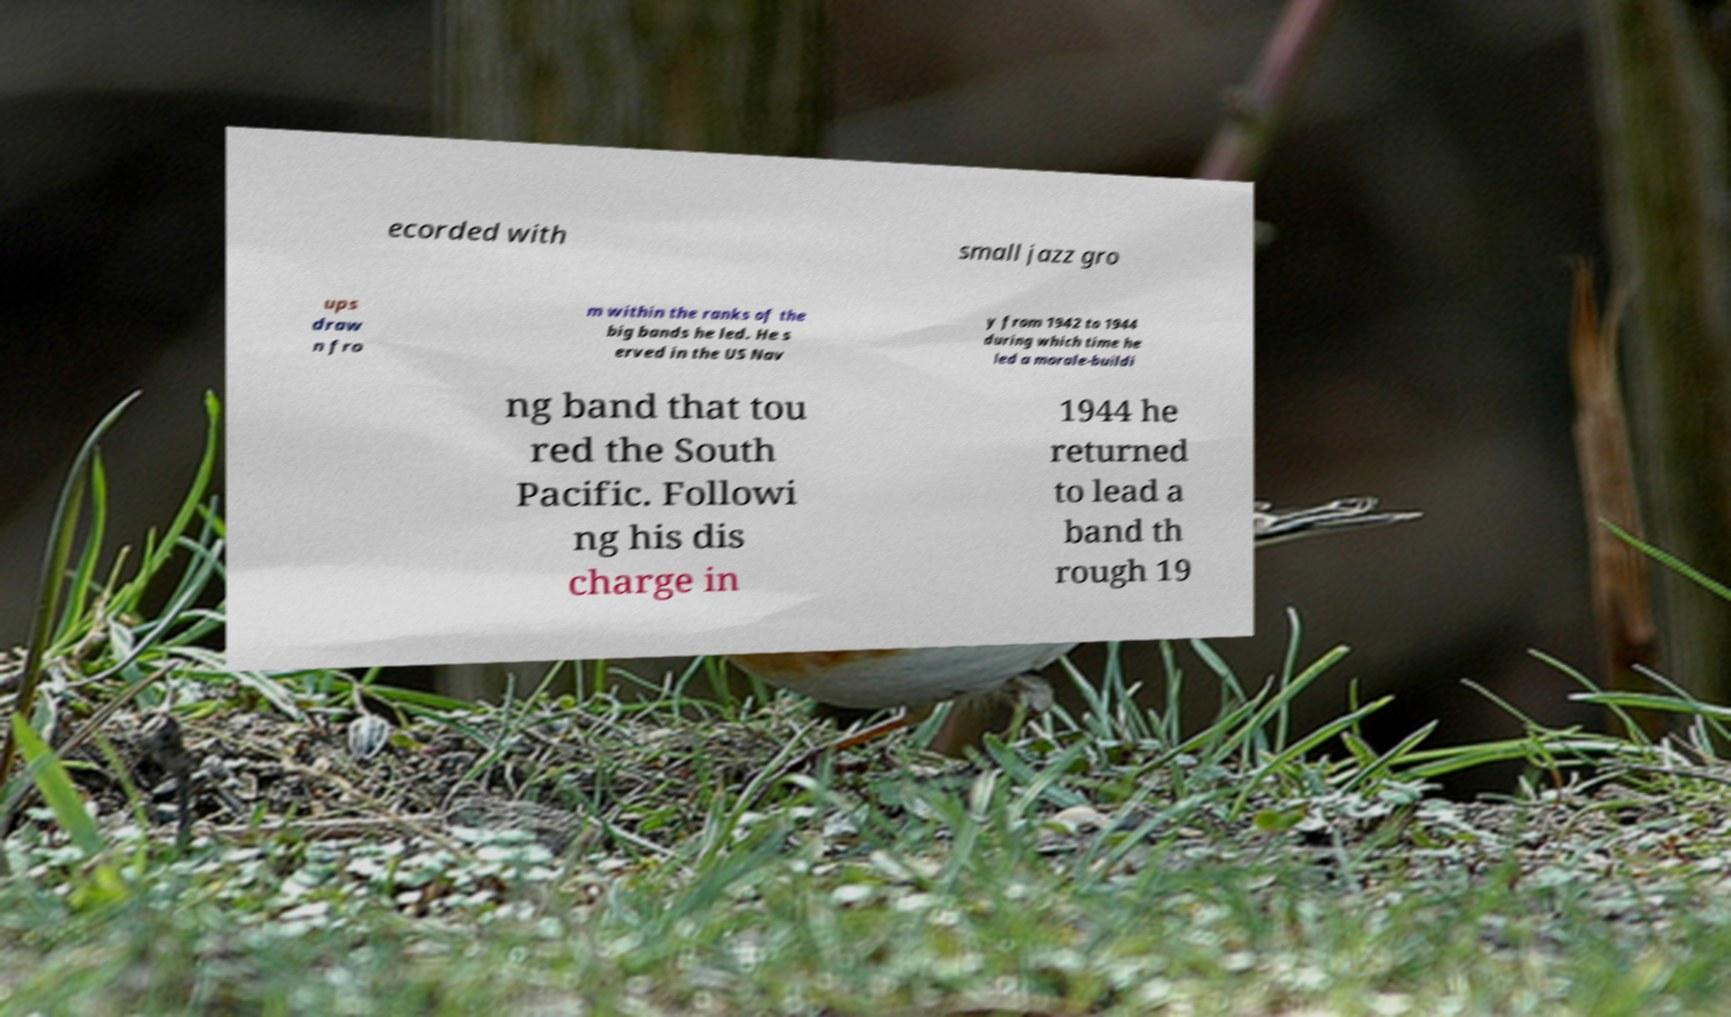For documentation purposes, I need the text within this image transcribed. Could you provide that? ecorded with small jazz gro ups draw n fro m within the ranks of the big bands he led. He s erved in the US Nav y from 1942 to 1944 during which time he led a morale-buildi ng band that tou red the South Pacific. Followi ng his dis charge in 1944 he returned to lead a band th rough 19 